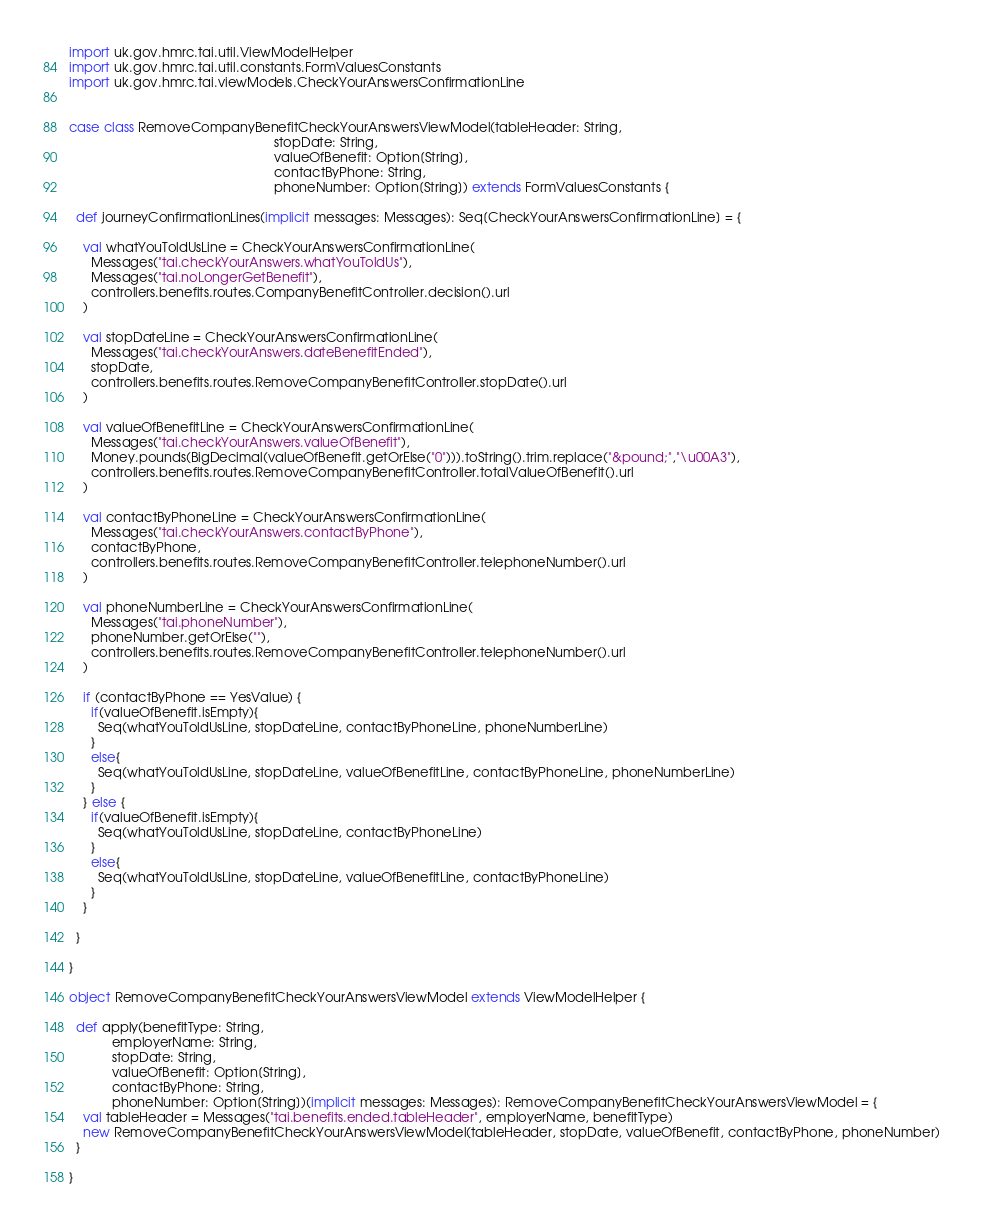Convert code to text. <code><loc_0><loc_0><loc_500><loc_500><_Scala_>import uk.gov.hmrc.tai.util.ViewModelHelper
import uk.gov.hmrc.tai.util.constants.FormValuesConstants
import uk.gov.hmrc.tai.viewModels.CheckYourAnswersConfirmationLine


case class RemoveCompanyBenefitCheckYourAnswersViewModel(tableHeader: String,
                                                         stopDate: String,
                                                         valueOfBenefit: Option[String],
                                                         contactByPhone: String,
                                                         phoneNumber: Option[String]) extends FormValuesConstants {

  def journeyConfirmationLines(implicit messages: Messages): Seq[CheckYourAnswersConfirmationLine] = {

    val whatYouToldUsLine = CheckYourAnswersConfirmationLine(
      Messages("tai.checkYourAnswers.whatYouToldUs"),
      Messages("tai.noLongerGetBenefit"),
      controllers.benefits.routes.CompanyBenefitController.decision().url
    )

    val stopDateLine = CheckYourAnswersConfirmationLine(
      Messages("tai.checkYourAnswers.dateBenefitEnded"),
      stopDate,
      controllers.benefits.routes.RemoveCompanyBenefitController.stopDate().url
    )

    val valueOfBenefitLine = CheckYourAnswersConfirmationLine(
      Messages("tai.checkYourAnswers.valueOfBenefit"),
      Money.pounds(BigDecimal(valueOfBenefit.getOrElse("0"))).toString().trim.replace("&pound;","\u00A3"),
      controllers.benefits.routes.RemoveCompanyBenefitController.totalValueOfBenefit().url
    )

    val contactByPhoneLine = CheckYourAnswersConfirmationLine(
      Messages("tai.checkYourAnswers.contactByPhone"),
      contactByPhone,
      controllers.benefits.routes.RemoveCompanyBenefitController.telephoneNumber().url
    )

    val phoneNumberLine = CheckYourAnswersConfirmationLine(
      Messages("tai.phoneNumber"),
      phoneNumber.getOrElse(""),
      controllers.benefits.routes.RemoveCompanyBenefitController.telephoneNumber().url
    )

    if (contactByPhone == YesValue) {
      if(valueOfBenefit.isEmpty){
        Seq(whatYouToldUsLine, stopDateLine, contactByPhoneLine, phoneNumberLine)
      }
      else{
        Seq(whatYouToldUsLine, stopDateLine, valueOfBenefitLine, contactByPhoneLine, phoneNumberLine)
      }
    } else {
      if(valueOfBenefit.isEmpty){
        Seq(whatYouToldUsLine, stopDateLine, contactByPhoneLine)
      }
      else{
        Seq(whatYouToldUsLine, stopDateLine, valueOfBenefitLine, contactByPhoneLine)
      }
    }

  }

}

object RemoveCompanyBenefitCheckYourAnswersViewModel extends ViewModelHelper {

  def apply(benefitType: String,
            employerName: String,
            stopDate: String,
            valueOfBenefit: Option[String],
            contactByPhone: String,
            phoneNumber: Option[String])(implicit messages: Messages): RemoveCompanyBenefitCheckYourAnswersViewModel = {
    val tableHeader = Messages("tai.benefits.ended.tableHeader", employerName, benefitType)
    new RemoveCompanyBenefitCheckYourAnswersViewModel(tableHeader, stopDate, valueOfBenefit, contactByPhone, phoneNumber)
  }

}

</code> 